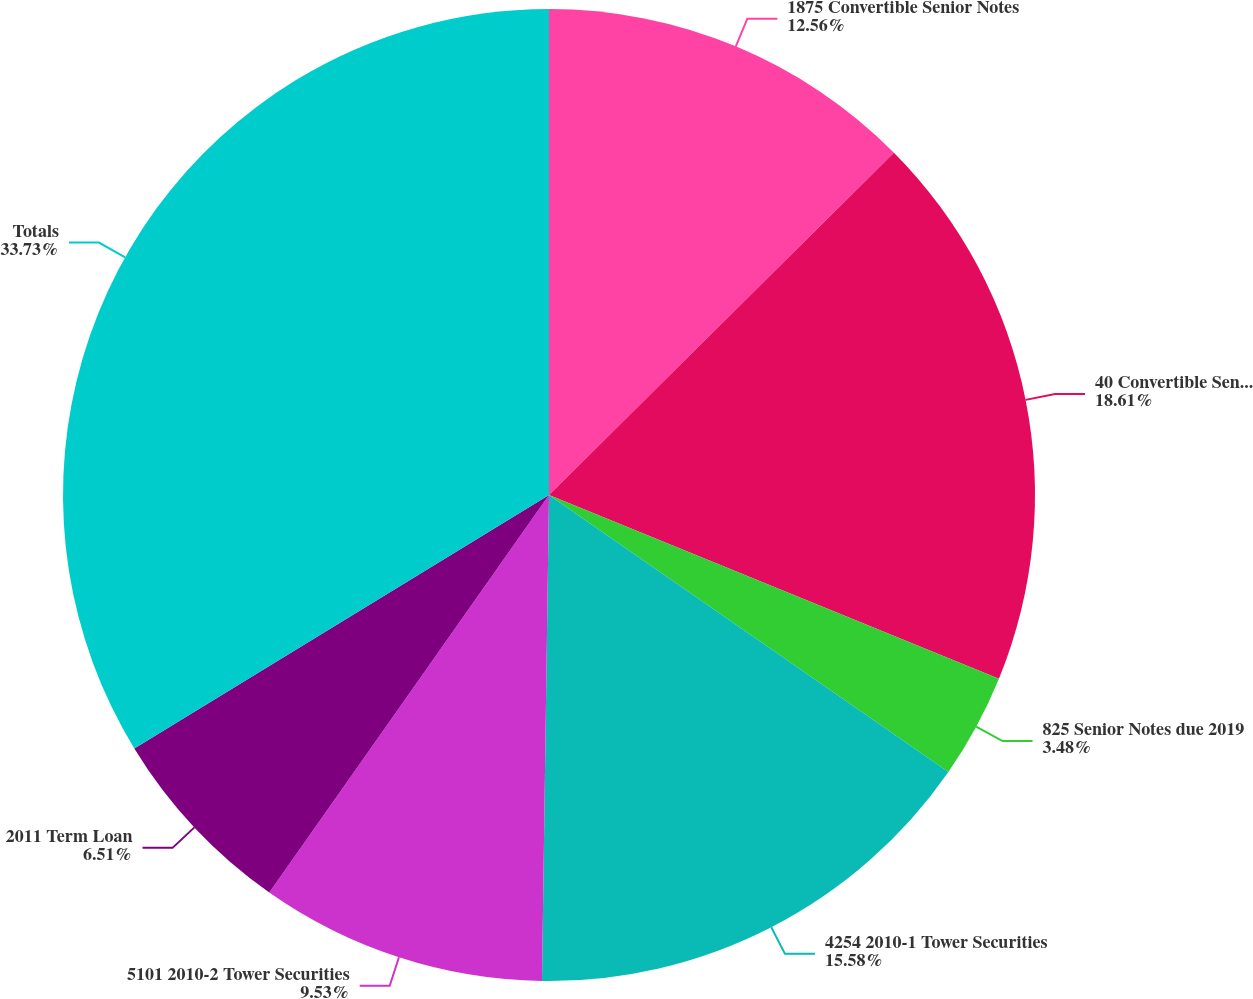<chart> <loc_0><loc_0><loc_500><loc_500><pie_chart><fcel>1875 Convertible Senior Notes<fcel>40 Convertible Senior Notes<fcel>825 Senior Notes due 2019<fcel>4254 2010-1 Tower Securities<fcel>5101 2010-2 Tower Securities<fcel>2011 Term Loan<fcel>Totals<nl><fcel>12.56%<fcel>18.61%<fcel>3.48%<fcel>15.58%<fcel>9.53%<fcel>6.51%<fcel>33.73%<nl></chart> 